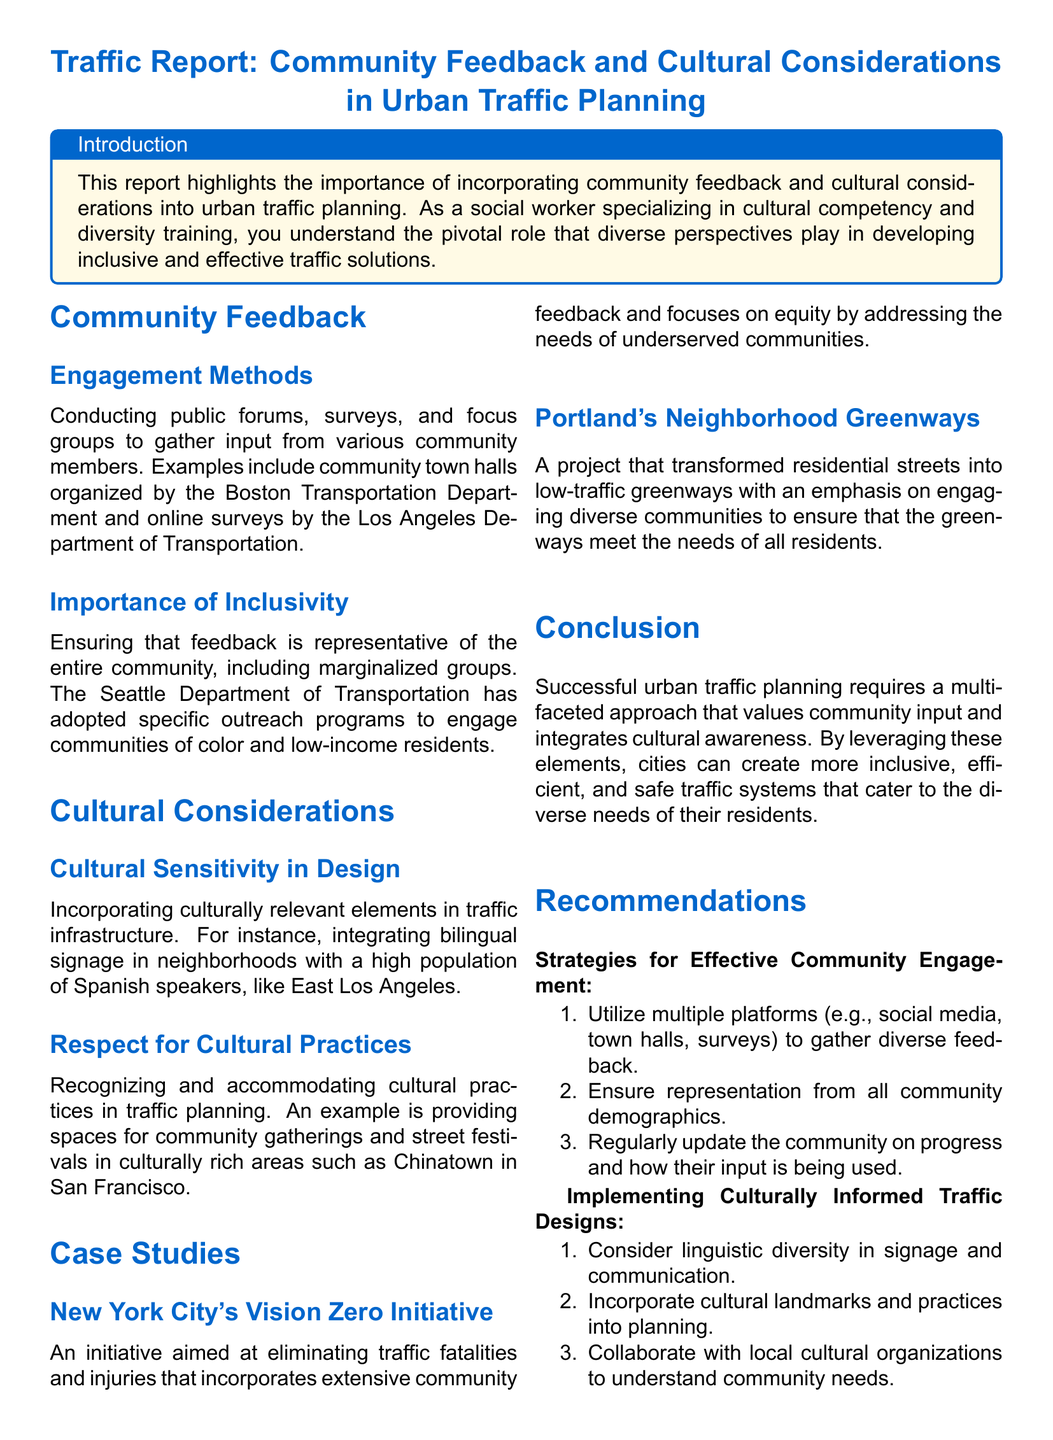What are the engagement methods mentioned? The report lists conducting public forums, surveys, and focus groups as engagement methods for gathering input.
Answer: public forums, surveys, and focus groups Which department organized town halls as part of community engagement? The report mentions the Boston Transportation Department in relation to community town halls.
Answer: Boston Transportation Department What initiative aims to eliminate traffic fatalities in New York City? The initiative mentioned in the report is called Vision Zero, aimed at eliminating traffic fatalities and injuries.
Answer: Vision Zero What community group does the Seattle Department of Transportation specifically engage? The report states that the Seattle Department of Transportation engages communities of color and low-income residents through outreach programs.
Answer: communities of color and low-income residents How many recommendations are provided for effective community engagement? The report outlines three strategies for effective community engagement.
Answer: 3 What cultural practice is recognized in traffic planning according to the document? The report recognizes the need for providing spaces for community gatherings and street festivals in culturally rich areas.
Answer: spaces for community gatherings and street festivals What is the primary goal of incorporating cultural sensitivity in traffic design? The goal is to incorporate culturally relevant elements in traffic infrastructure.
Answer: incorporate culturally relevant elements Which city's project transformed residential streets into greenways? Portland’s Neighborhood Greenways project is mentioned as transforming residential streets into low-traffic greenways.
Answer: Portland's Neighborhood Greenways What should traffic designs consider regarding linguistic diversity? The report suggests considering linguistic diversity in signage and communication for effective traffic design.
Answer: linguistic diversity in signage and communication 